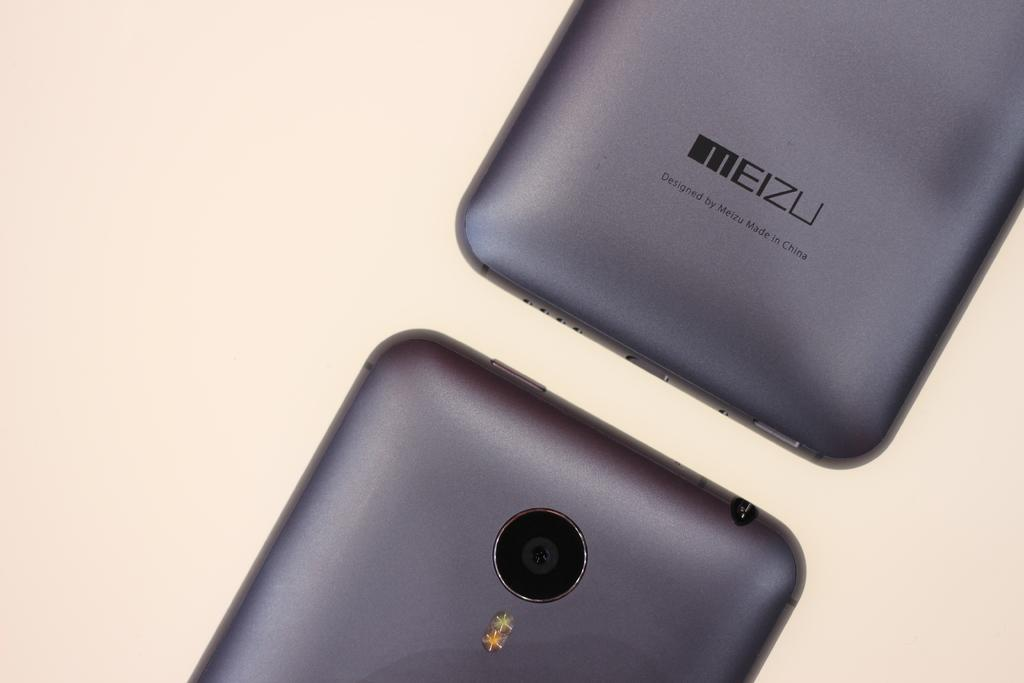<image>
Write a terse but informative summary of the picture. Two grey Meizu phones with the ends close together. 